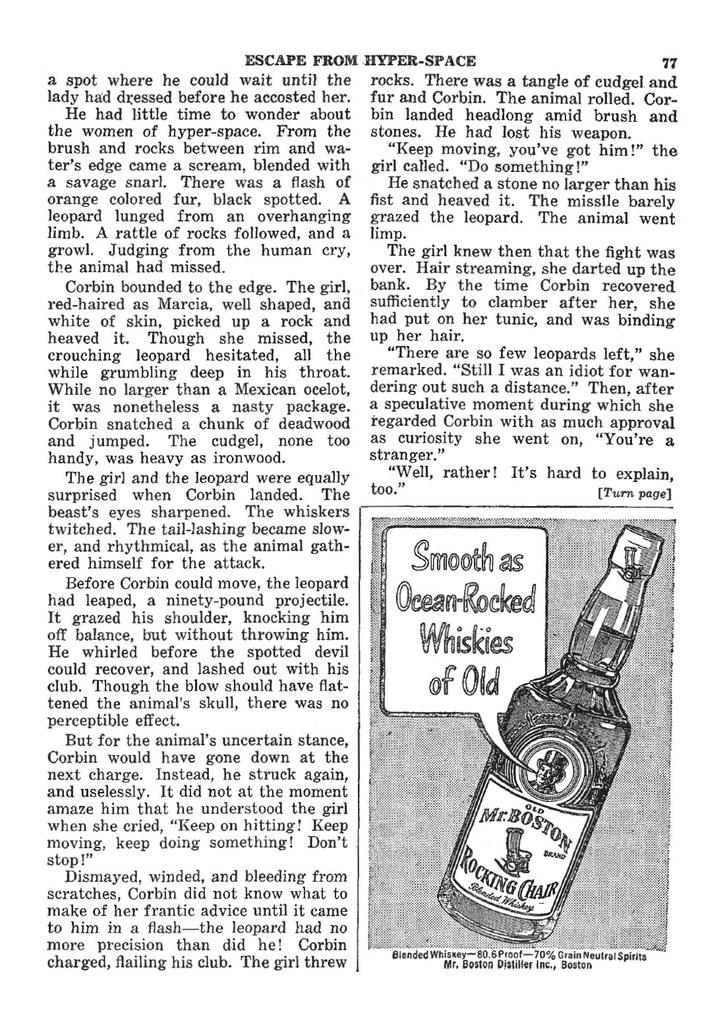<image>
Offer a succinct explanation of the picture presented. Page 77 from the book Escape from Hyper-space. 